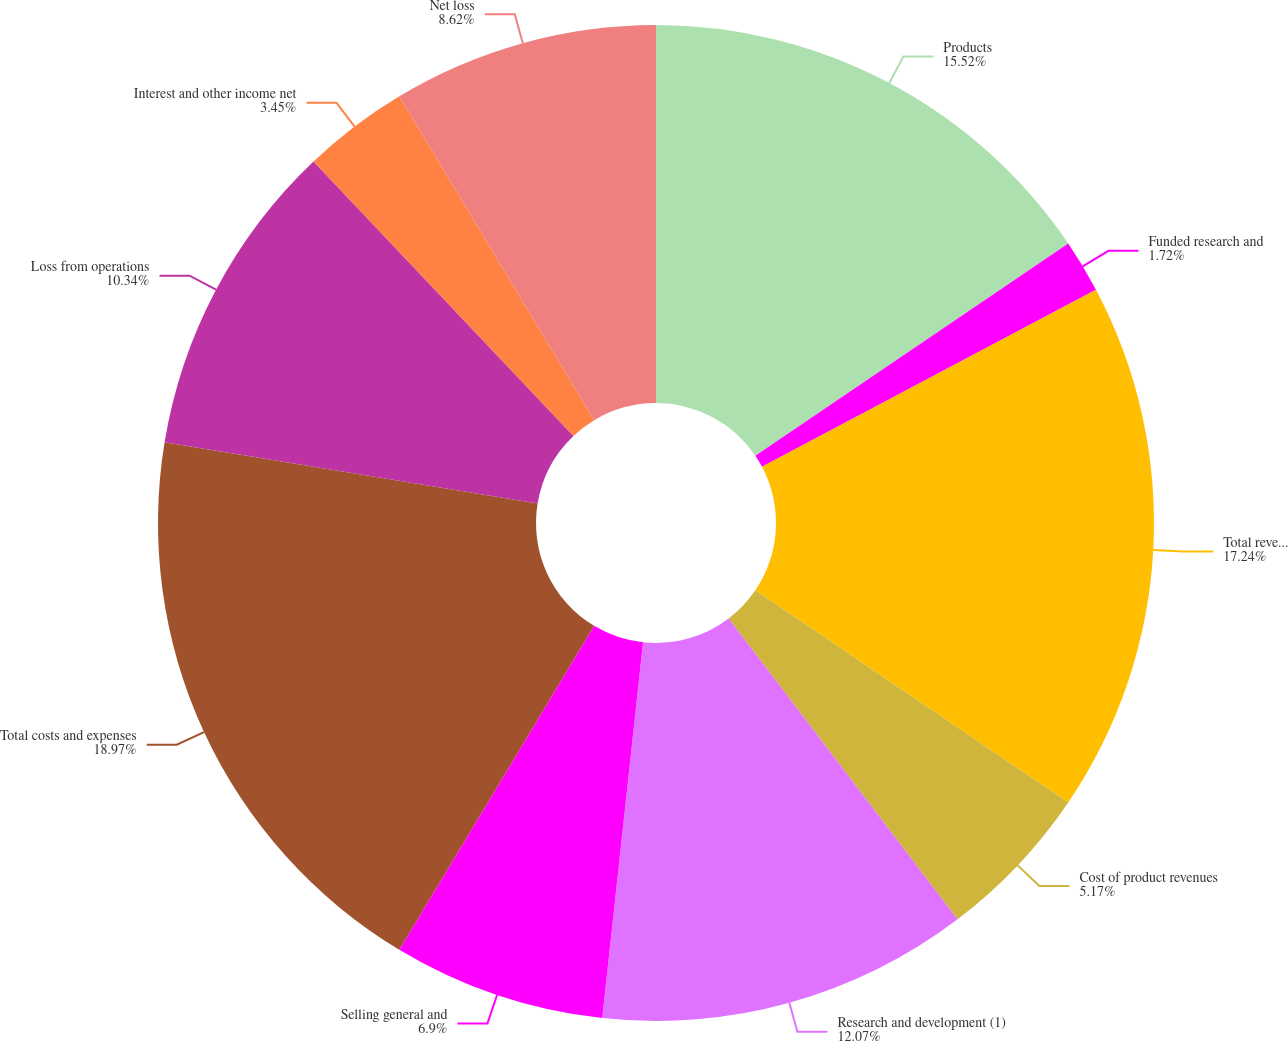Convert chart to OTSL. <chart><loc_0><loc_0><loc_500><loc_500><pie_chart><fcel>Products<fcel>Funded research and<fcel>Total revenues<fcel>Cost of product revenues<fcel>Research and development (1)<fcel>Selling general and<fcel>Total costs and expenses<fcel>Loss from operations<fcel>Interest and other income net<fcel>Net loss<nl><fcel>15.52%<fcel>1.72%<fcel>17.24%<fcel>5.17%<fcel>12.07%<fcel>6.9%<fcel>18.97%<fcel>10.34%<fcel>3.45%<fcel>8.62%<nl></chart> 